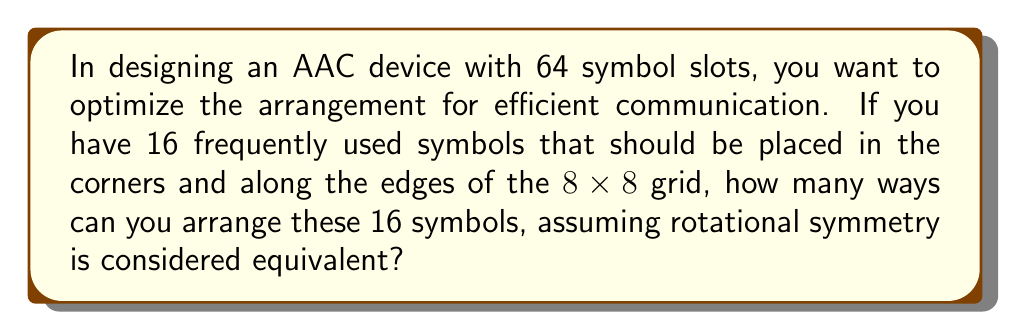Could you help me with this problem? Let's approach this step-by-step:

1) First, we need to identify the number of unique positions for the 16 symbols:
   - 4 corner positions
   - 12 edge positions (excluding corners)

2) Due to rotational symmetry, we can fix one corner symbol. This leaves us with 15 symbols to arrange.

3) For the remaining 3 corners, we have:
   $${15 \choose 3} = 455$$ ways to choose the symbols

4) For the 12 edge positions, we have:
   $$12! = 479,001,600$$ ways to arrange the remaining 12 symbols

5) However, due to rotational symmetry, we need to divide this by 4 (as rotations of 0°, 90°, 180°, and 270° are considered equivalent):

   $$\frac{12!}{4} = 119,750,400$$

6) By the multiplication principle, the total number of unique arrangements is:

   $$455 \times 119,750,400 = 54,486,432,000$$

Therefore, there are 54,486,432,000 unique ways to arrange the 16 symbols on the AAC device, considering rotational symmetry.
Answer: 54,486,432,000 